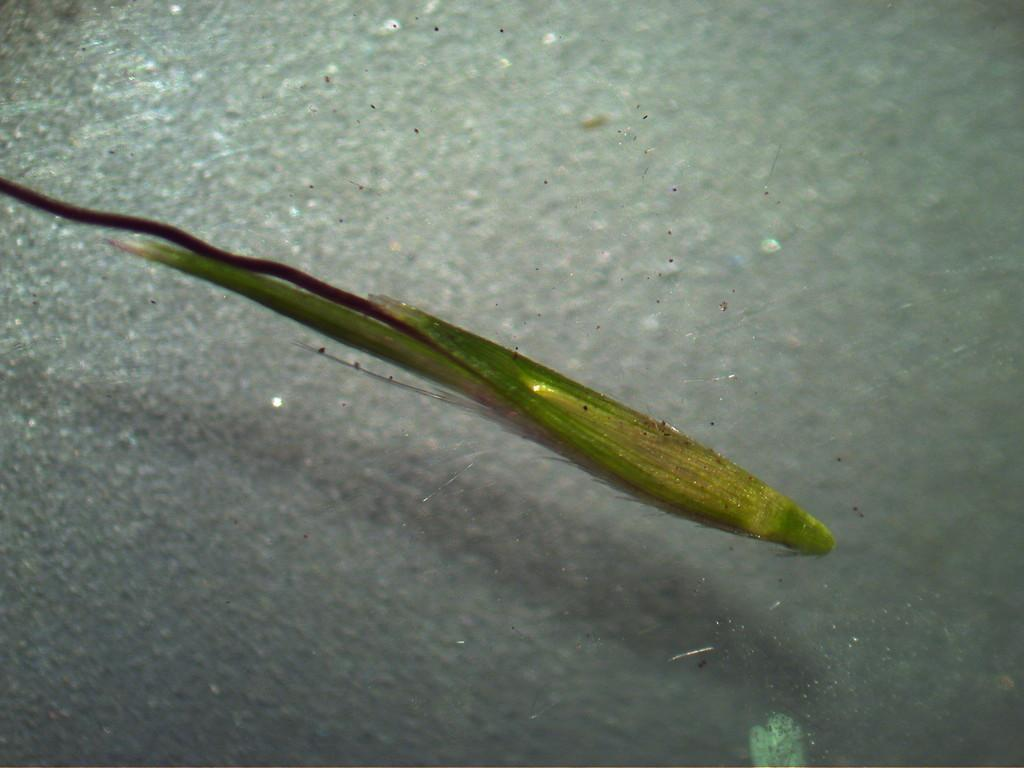What type of animal can be seen in the image? There is an aquatic animal in the image. What does the aquatic animal resemble? The aquatic animal looks like a fish. Where is the aquatic animal located? The aquatic animal is in water. What type of farm animal can be seen in the image? There is no farm animal present in the image; it features an aquatic animal that resembles a fish in water. Can you tell me how many lawyers are depicted in the image? There are no lawyers depicted in the image; it features an aquatic animal that resembles a fish in water. 